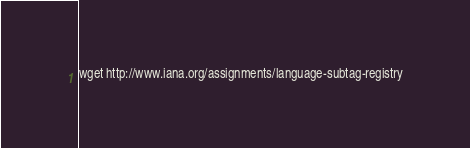Convert code to text. <code><loc_0><loc_0><loc_500><loc_500><_Bash_>wget http://www.iana.org/assignments/language-subtag-registry
</code> 